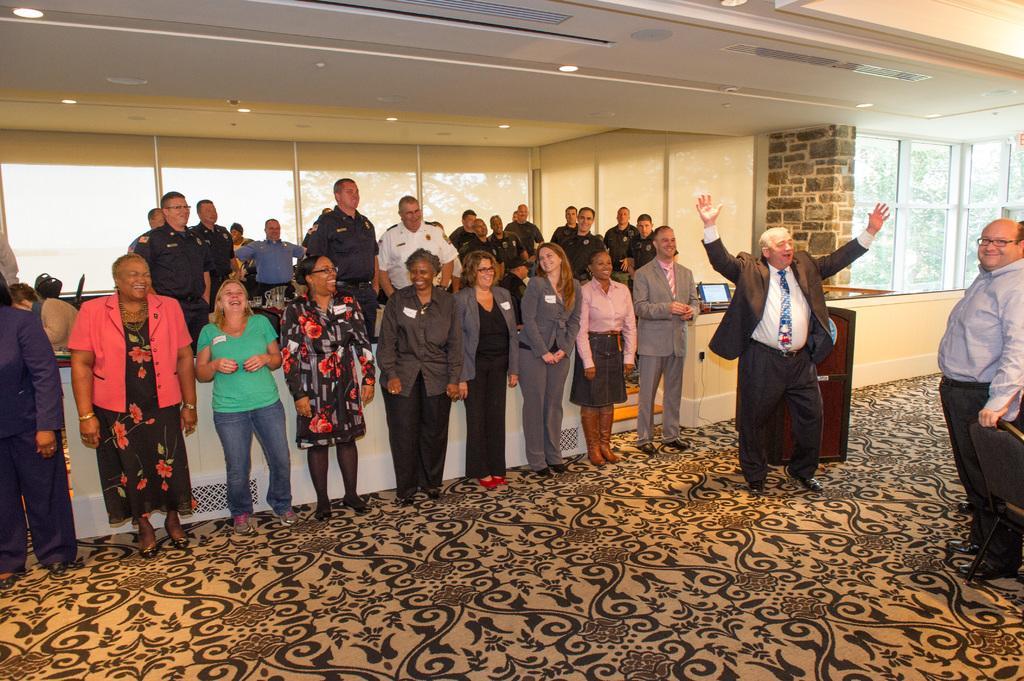Describe this image in one or two sentences. In this picture I can see in the middle a group of people are standing and also laughing, on the right side a man is standing by raising his hands. In the background there are glass windows, at the top there are ceiling lights. 